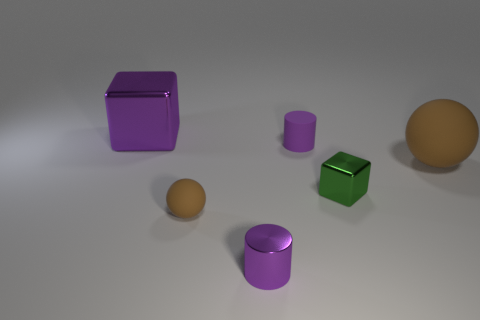Does the brown ball that is to the right of the small matte cylinder have the same material as the tiny green thing?
Offer a very short reply. No. What number of objects are either small blue rubber spheres or metallic cubes?
Your response must be concise. 2. There is another thing that is the same shape as the green thing; what is its size?
Your answer should be very brief. Large. The green shiny object is what size?
Your answer should be compact. Small. Are there more purple metallic cylinders behind the matte cylinder than small metal cylinders?
Keep it short and to the point. No. Is there anything else that is made of the same material as the big purple block?
Your response must be concise. Yes. There is a shiny block in front of the large purple shiny thing; is it the same color as the ball on the left side of the small rubber cylinder?
Make the answer very short. No. What material is the purple cylinder that is behind the brown sphere left of the purple cylinder behind the small brown rubber sphere?
Offer a terse response. Rubber. Are there more small rubber things than tiny green metallic cubes?
Provide a short and direct response. Yes. Are there any other things of the same color as the tiny block?
Offer a very short reply. No. 